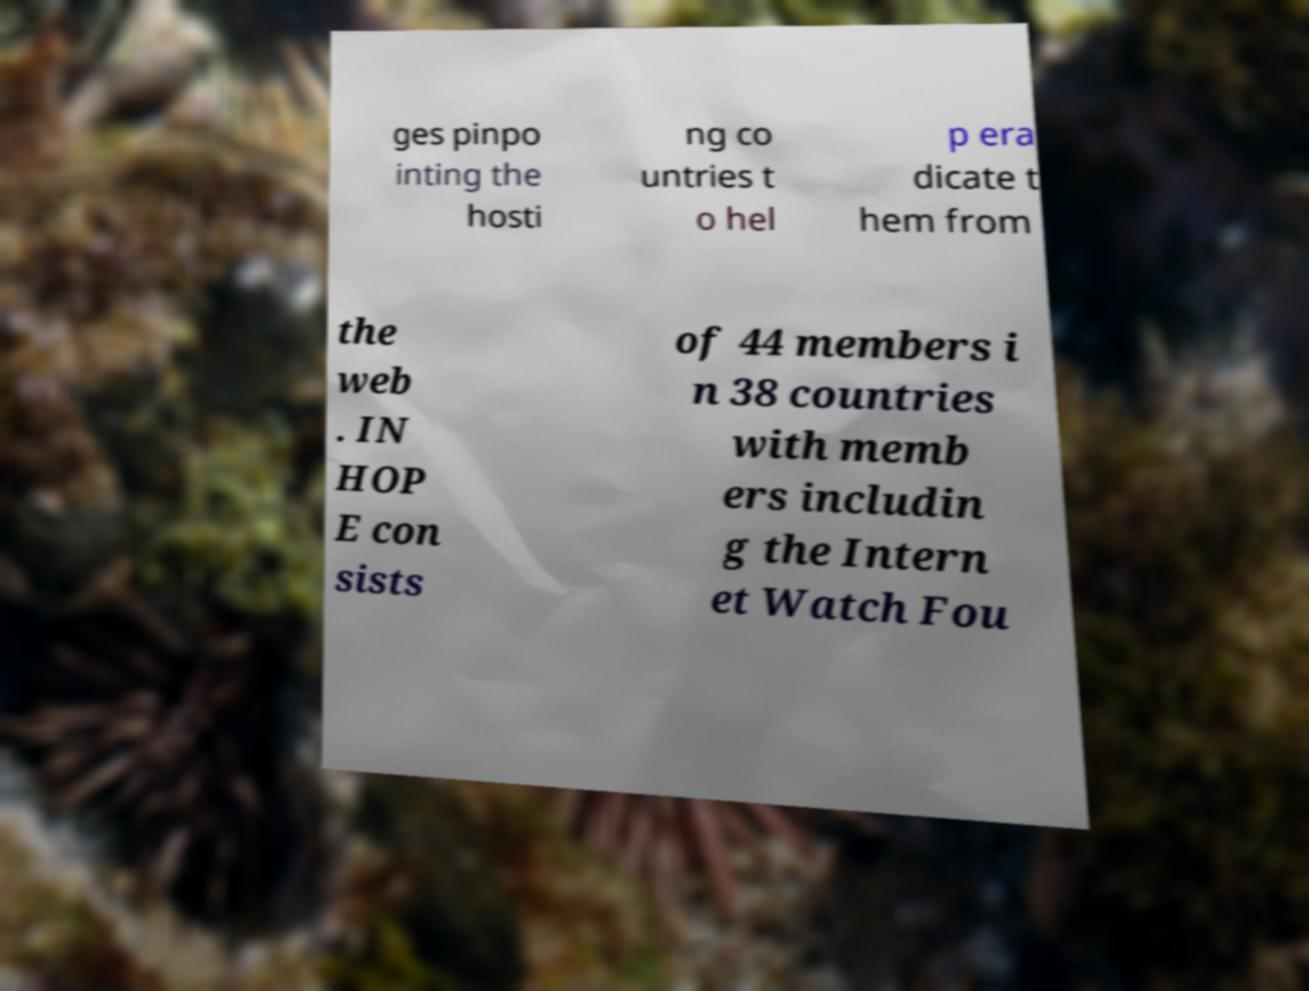Please read and relay the text visible in this image. What does it say? ges pinpo inting the hosti ng co untries t o hel p era dicate t hem from the web . IN HOP E con sists of 44 members i n 38 countries with memb ers includin g the Intern et Watch Fou 